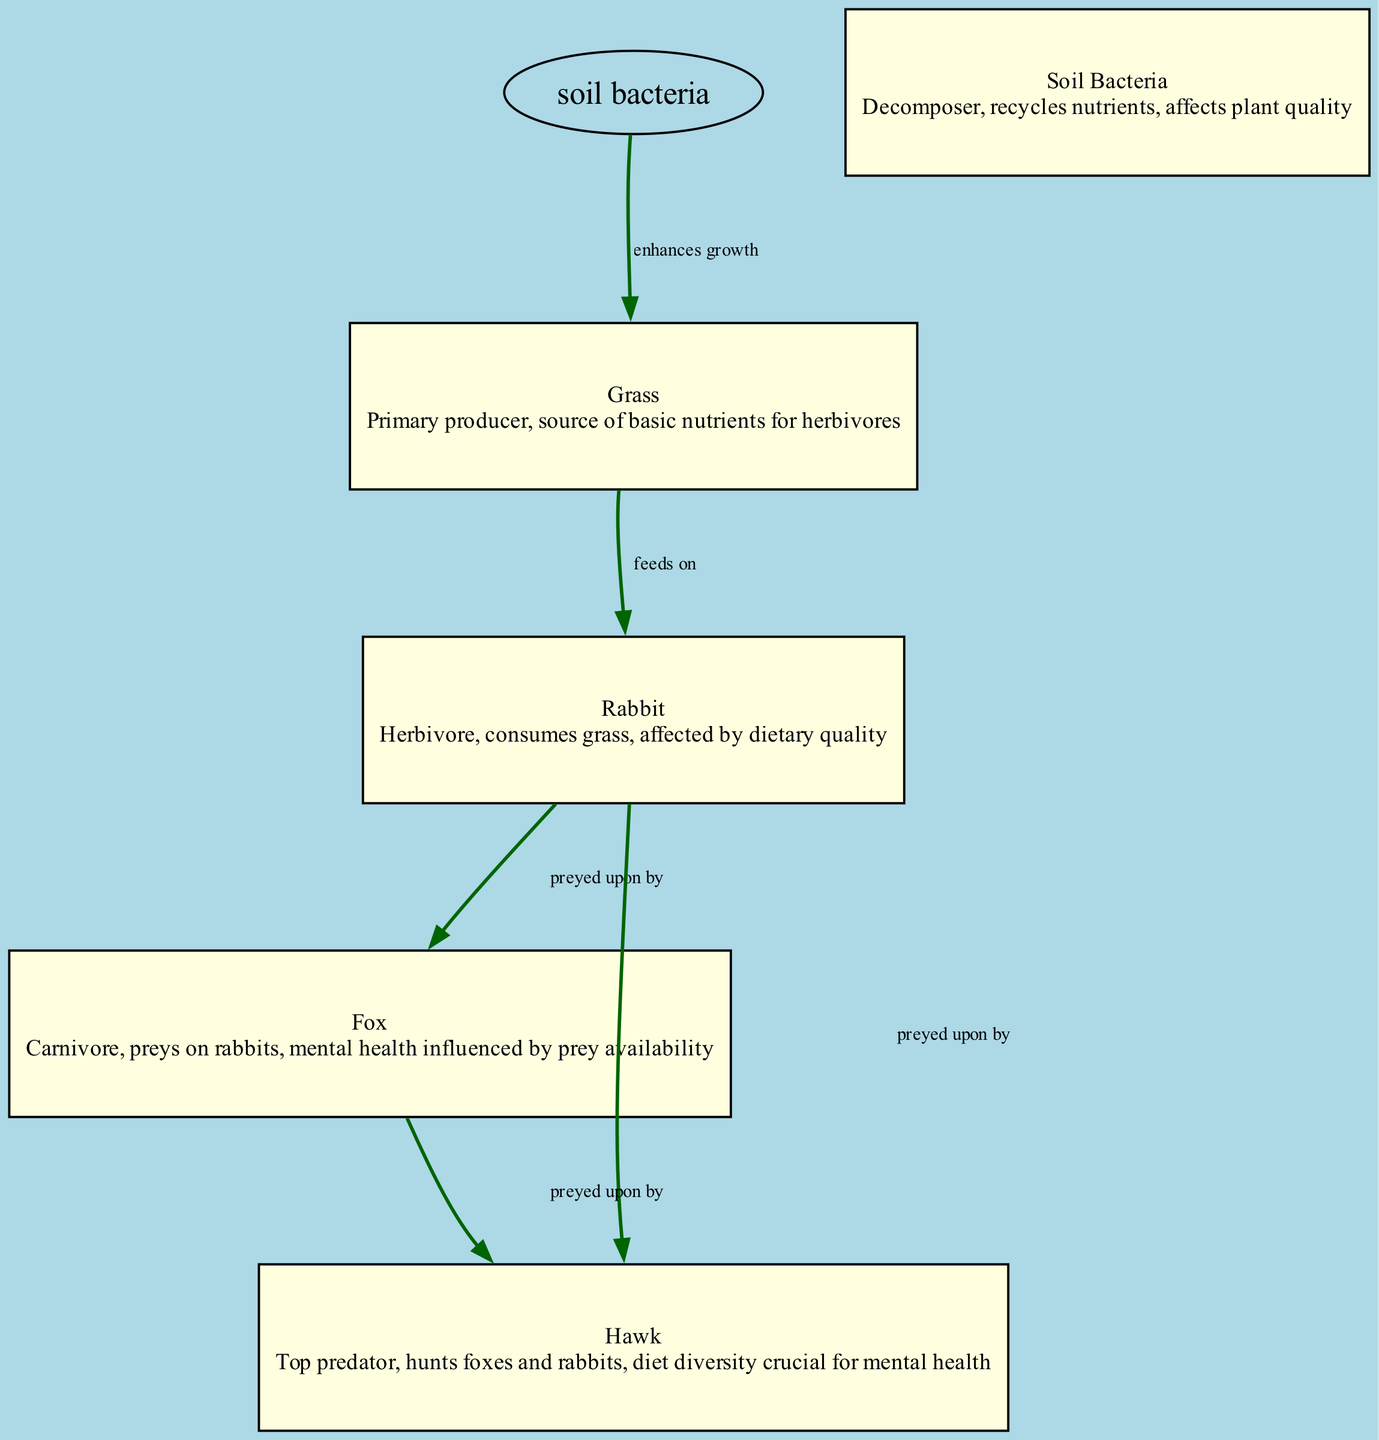What is the primary producer in this food chain? The diagram identifies "Grass" as the primary producer, which is the first node in the flow that provides nutrients to herbivores.
Answer: Grass How many herbivores are present in the diagram? There is a single herbivore node labeled "Rabbit," which directly consumes grass.
Answer: 1 What does "Soil Bacteria" enhance the growth of? The diagram indicates that "Soil Bacteria" enhances the growth of "Grass," providing a direct relationship between these two nodes.
Answer: Grass Who preys on rabbits? The diagram shows two predators, "Fox" and "Hawk," both of which are connected by arrows indicating predation on rabbits.
Answer: Fox and Hawk What is the impact of diet diversity on the hawk's mental health according to the diagram? The diagram states that diet diversity is crucial for the mental health of the "Hawk," implying that a diverse diet positively contributes to its mental well-being.
Answer: Crucial Explain how soil bacteria affect the overall ecosystem. "Soil Bacteria" play a role in recycling nutrients through decomposition, which enhances the growth of "Grass." This provides a better nutritional base for "Rabbits," impacting herbivore health, which consequently affects predators like "Fox" and "Hawk" as prey availability is linked to the health of herbivores. Thus, soil bacteria indirectly influence the entire food chain's dynamics and mental health across species.
Answer: Enhances grass growth What is the last node in this food chain? The "Hawk" is depicted as the top predator, which ends the food chain by preying on both "Fox" and "Rabbit," making it the last node present.
Answer: Hawk How does the quality of the rabbit's diet affect it? According to the diagram, the rabbit's mental health is affected by dietary quality, meaning that the nutrients and variety in its diet can influence its well-being.
Answer: Affected by dietary quality Who is at the highest level in the food chain? The "Hawk" is identified as the top predator in the diagram, positioned at the highest level in the food chain structure.
Answer: Hawk 